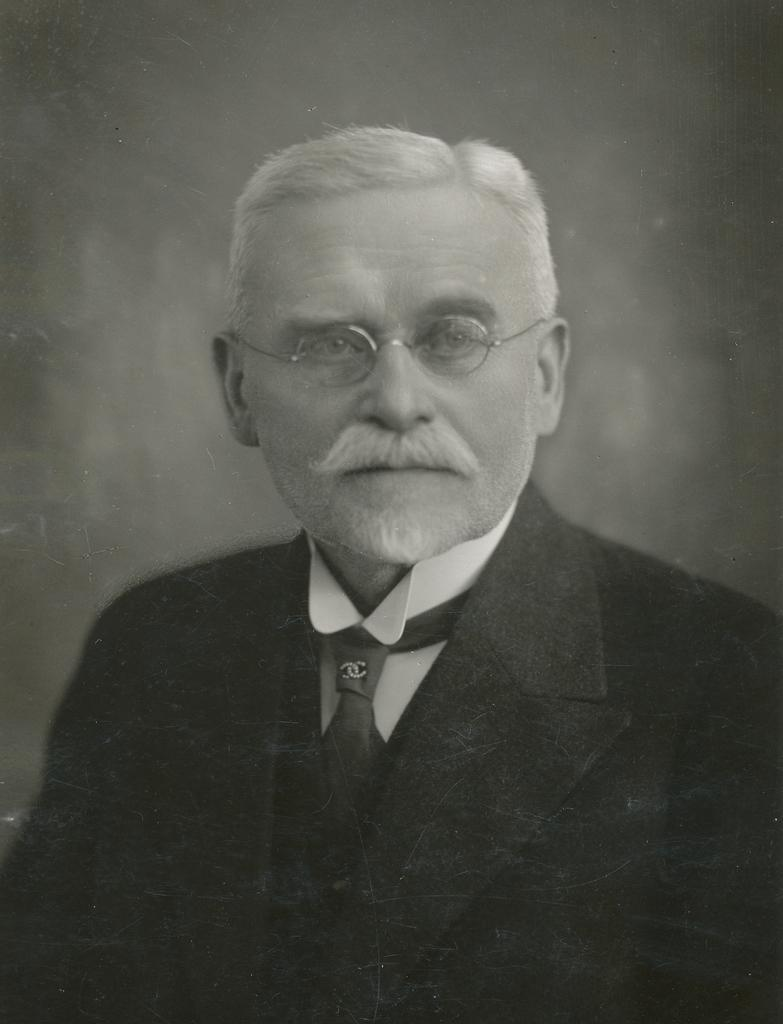What is the color scheme of the image? The image is black and white. Who is present in the image? There is a man in the image. What is the man wearing? The man is wearing a suit. What is the man doing in the image? The man is looking at a picture. How is the background of the image represented? The background of the image is blurred. Is there an umbrella visible in the image to protect the man from the thunder? There is no umbrella or mention of thunder in the image; it is a black and white image of a man looking at a picture with a blurred background. 